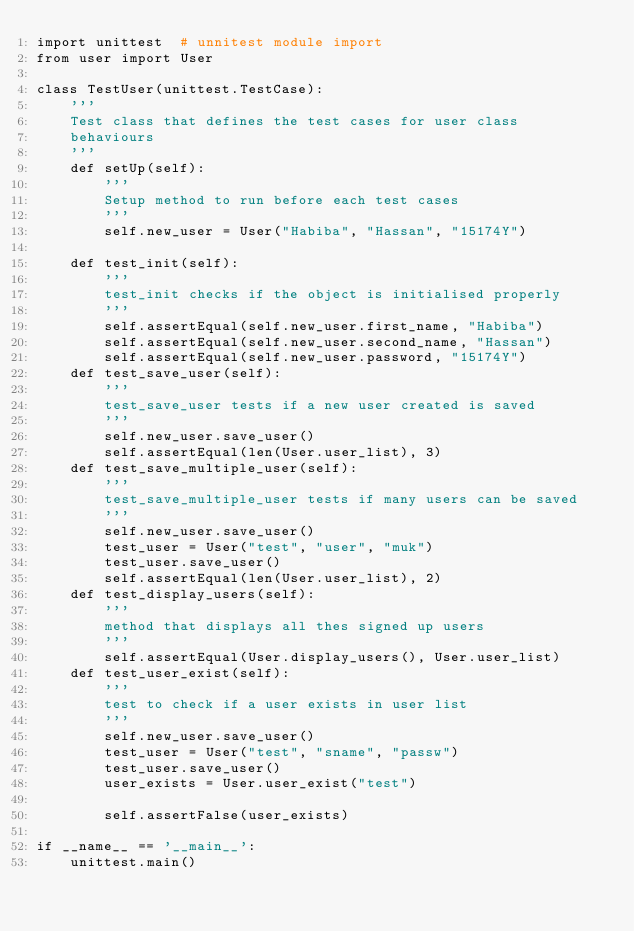<code> <loc_0><loc_0><loc_500><loc_500><_Python_>import unittest  # unnitest module import
from user import User

class TestUser(unittest.TestCase):
    '''
    Test class that defines the test cases for user class
    behaviours
    '''
    def setUp(self):
        '''
        Setup method to run before each test cases
        '''
        self.new_user = User("Habiba", "Hassan", "15174Y")

    def test_init(self):
        '''
        test_init checks if the object is initialised properly
        '''
        self.assertEqual(self.new_user.first_name, "Habiba")
        self.assertEqual(self.new_user.second_name, "Hassan")
        self.assertEqual(self.new_user.password, "15174Y")
    def test_save_user(self):
        '''
        test_save_user tests if a new user created is saved
        '''
        self.new_user.save_user()
        self.assertEqual(len(User.user_list), 3)
    def test_save_multiple_user(self):
        '''
        test_save_multiple_user tests if many users can be saved
        '''
        self.new_user.save_user()
        test_user = User("test", "user", "muk")
        test_user.save_user()
        self.assertEqual(len(User.user_list), 2)
    def test_display_users(self):
        '''
        method that displays all thes signed up users
        '''
        self.assertEqual(User.display_users(), User.user_list)
    def test_user_exist(self):
        '''
        test to check if a user exists in user list
        '''
        self.new_user.save_user()
        test_user = User("test", "sname", "passw")
        test_user.save_user()
        user_exists = User.user_exist("test")

        self.assertFalse(user_exists)

if __name__ == '__main__':
    unittest.main()</code> 